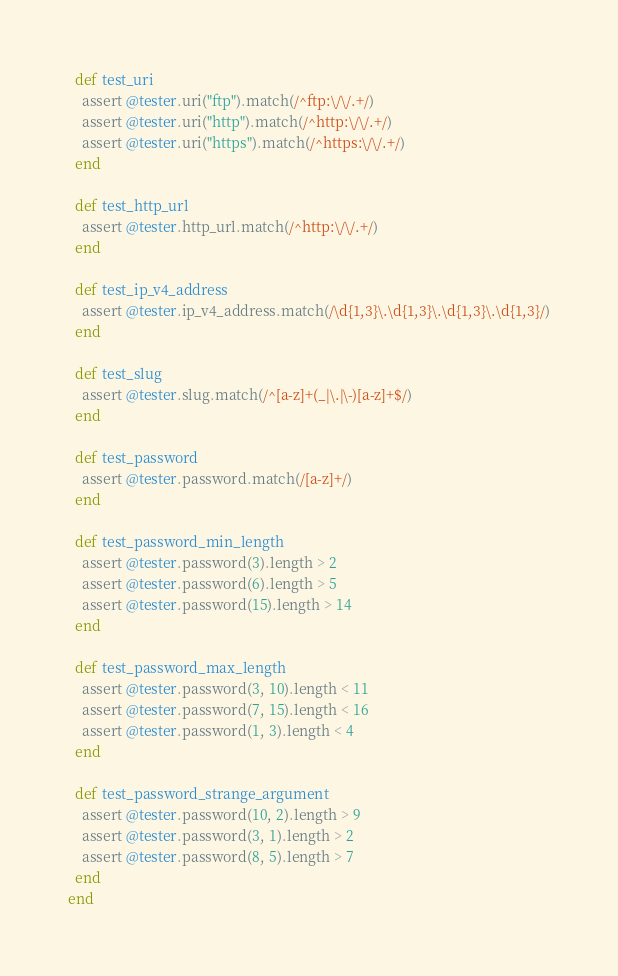Convert code to text. <code><loc_0><loc_0><loc_500><loc_500><_Ruby_>
  def test_uri
    assert @tester.uri("ftp").match(/^ftp:\/\/.+/)
    assert @tester.uri("http").match(/^http:\/\/.+/)
    assert @tester.uri("https").match(/^https:\/\/.+/)
  end

  def test_http_url
    assert @tester.http_url.match(/^http:\/\/.+/)
  end

  def test_ip_v4_address
    assert @tester.ip_v4_address.match(/\d{1,3}\.\d{1,3}\.\d{1,3}\.\d{1,3}/)
  end

  def test_slug
    assert @tester.slug.match(/^[a-z]+(_|\.|\-)[a-z]+$/)
  end

  def test_password
    assert @tester.password.match(/[a-z]+/)
  end

  def test_password_min_length
    assert @tester.password(3).length > 2
    assert @tester.password(6).length > 5
    assert @tester.password(15).length > 14
  end

  def test_password_max_length
    assert @tester.password(3, 10).length < 11
    assert @tester.password(7, 15).length < 16
    assert @tester.password(1, 3).length < 4
  end

  def test_password_strange_argument
    assert @tester.password(10, 2).length > 9
    assert @tester.password(3, 1).length > 2
    assert @tester.password(8, 5).length > 7
  end
end
</code> 